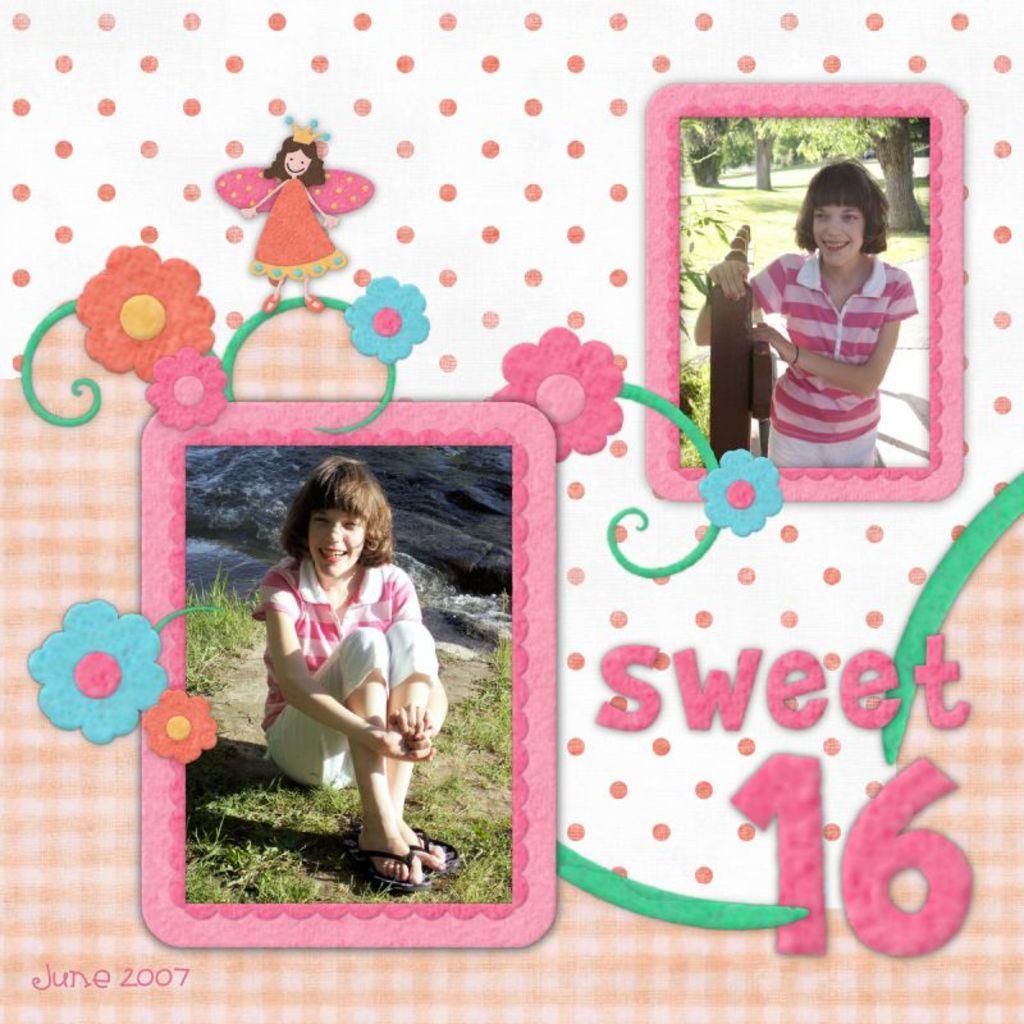In one or two sentences, can you explain what this image depicts? This is an edited and made as college. In this image I can see two pictures. In the two pictures I can see the same person. In the left side picture this person is sitting on the ground and smiling. At the back of this person I can see the water. In the right side picture this person is standing by holding a metal rod and smiling. In the background I can see the trees. On this image I can see some edited text and few cartoon images. 